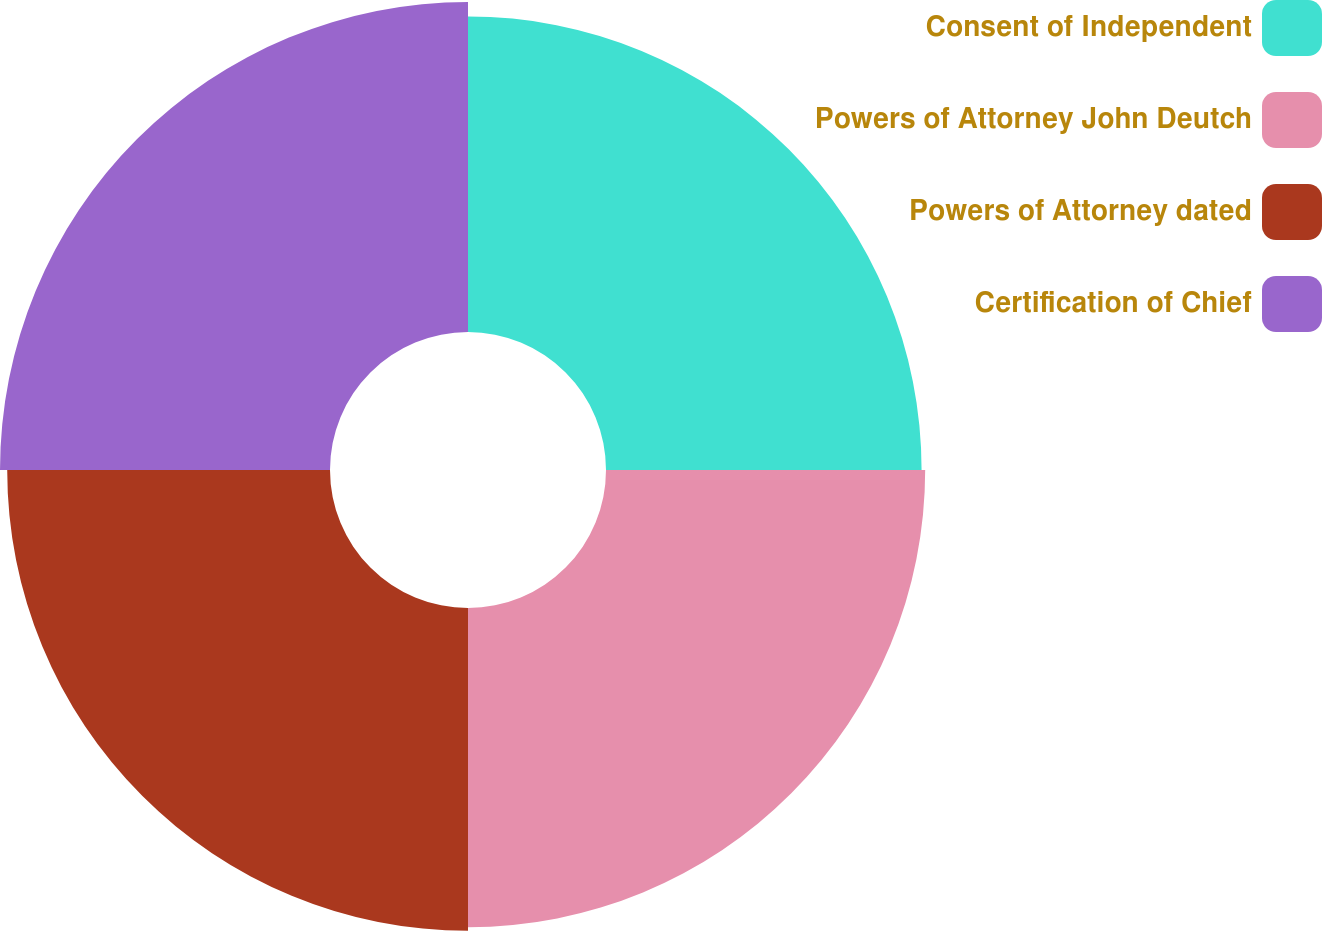Convert chart to OTSL. <chart><loc_0><loc_0><loc_500><loc_500><pie_chart><fcel>Consent of Independent<fcel>Powers of Attorney John Deutch<fcel>Powers of Attorney dated<fcel>Certification of Chief<nl><fcel>24.51%<fcel>24.79%<fcel>25.07%<fcel>25.63%<nl></chart> 